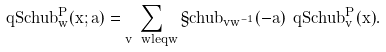<formula> <loc_0><loc_0><loc_500><loc_500>\ q S c h u b ^ { P } _ { w } ( x ; a ) = \sum _ { v \ w l e q w } \S c h u b _ { v w ^ { - 1 } } ( - a ) \ q S c h u b ^ { P } _ { v } ( x ) .</formula> 